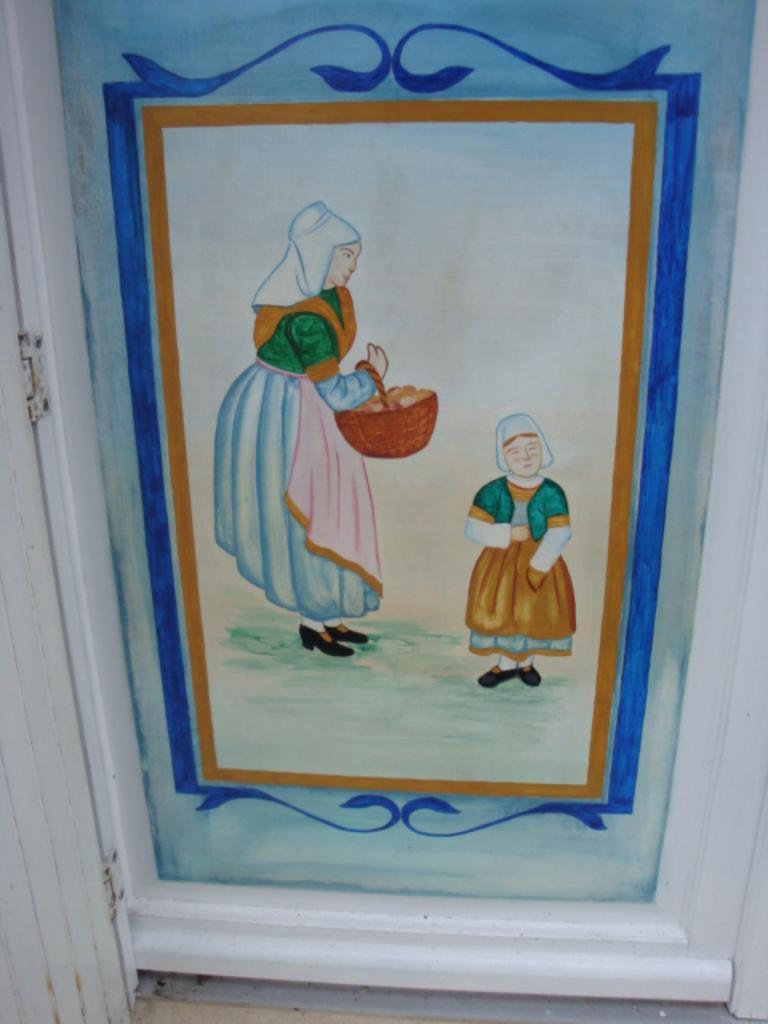Describe this image in one or two sentences. In this picture in the center there is a frame. On the frame there is a painting of a woman and a child. 